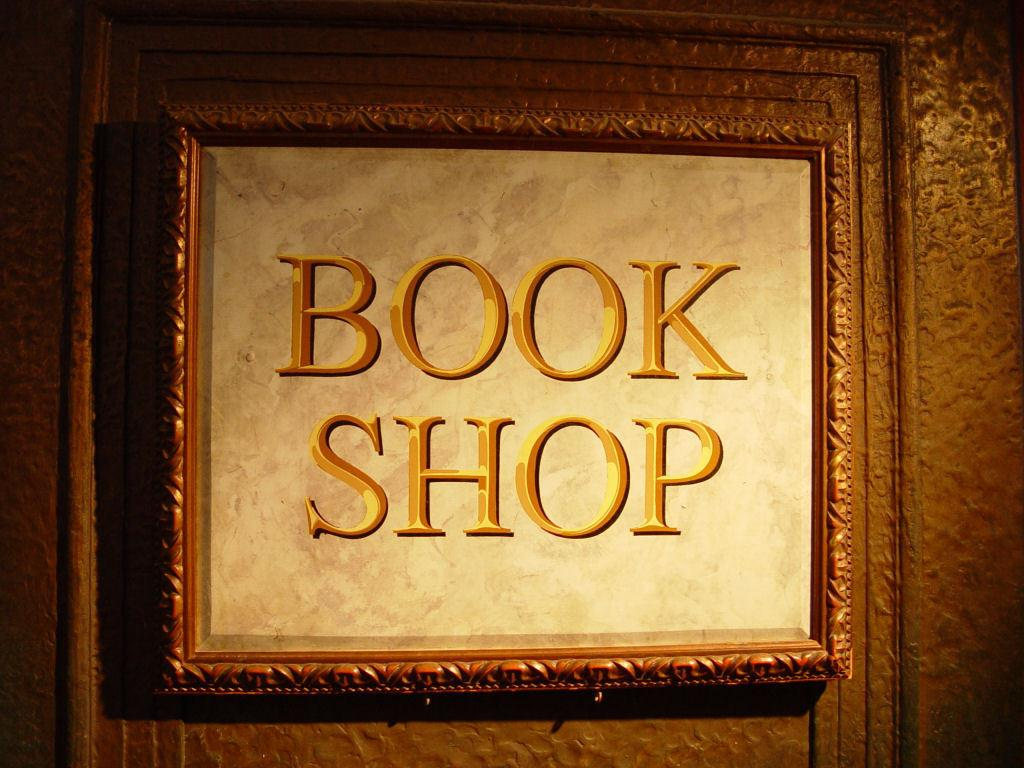<image>
Provide a brief description of the given image. A gold framed sign that reads Book Shop 